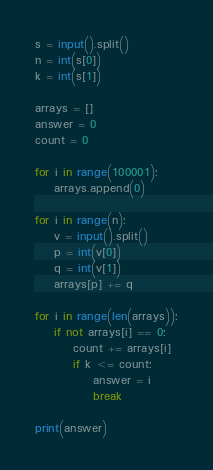<code> <loc_0><loc_0><loc_500><loc_500><_Python_>s = input().split()
n = int(s[0])
k = int(s[1])

arrays = []
answer = 0
count = 0

for i in range(100001):
    arrays.append(0)

for i in range(n):
    v = input().split()
    p = int(v[0])
    q = int(v[1])
    arrays[p] += q

for i in range(len(arrays)):
    if not arrays[i] == 0:
        count += arrays[i]
        if k <= count:
            answer = i
            break

print(answer)

</code> 